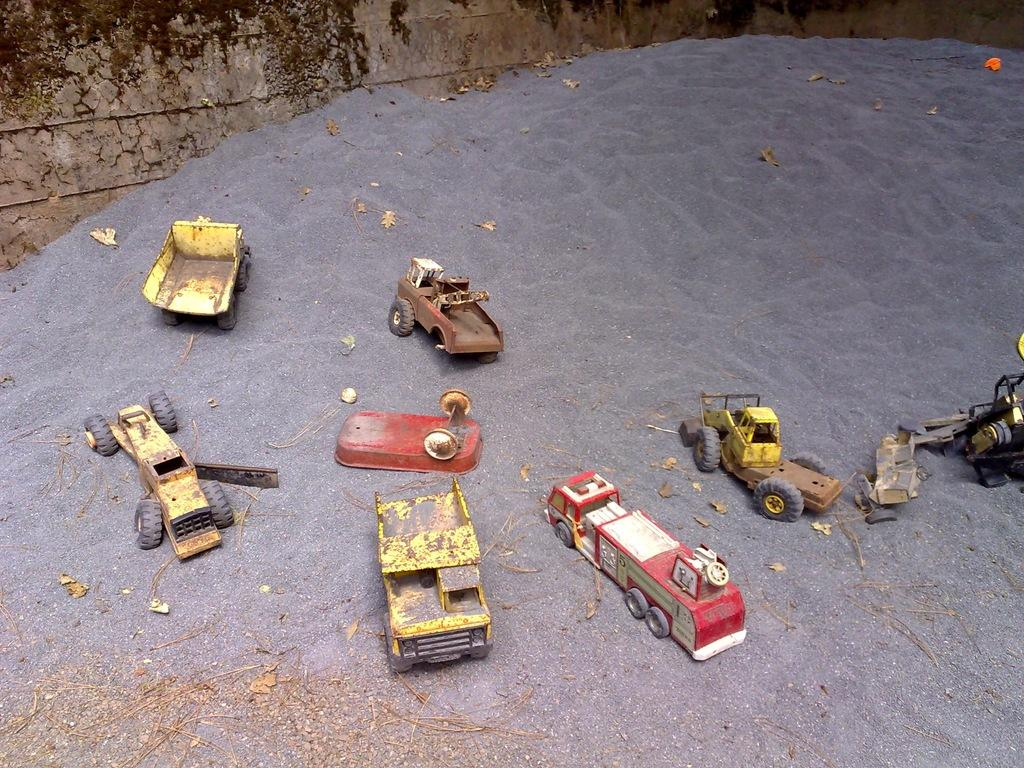What can be seen at the bottom of the image? The ground is visible in the image. What type of objects are present on the ground? There are toy vehicles in the image. What colors are the toy vehicles? The toy vehicles are red, white, black, and yellow in color. What is visible in the background of the image? There is a wall in the background of the image. What type of wine is being served during the discussion in the image? There is no discussion or wine present in the image; it features toy vehicles on the ground and a wall in the background. 